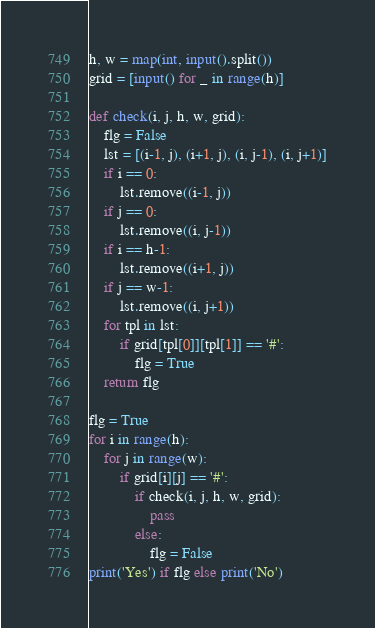<code> <loc_0><loc_0><loc_500><loc_500><_Python_>h, w = map(int, input().split())
grid = [input() for _ in range(h)]

def check(i, j, h, w, grid):
    flg = False
    lst = [(i-1, j), (i+1, j), (i, j-1), (i, j+1)]
    if i == 0:
        lst.remove((i-1, j))
    if j == 0:
        lst.remove((i, j-1))
    if i == h-1:
        lst.remove((i+1, j))
    if j == w-1:
        lst.remove((i, j+1))
    for tpl in lst:
        if grid[tpl[0]][tpl[1]] == '#':
            flg = True
    return flg

flg = True
for i in range(h):
    for j in range(w):
        if grid[i][j] == '#':
            if check(i, j, h, w, grid):
                pass
            else:
                flg = False
print('Yes') if flg else print('No')</code> 